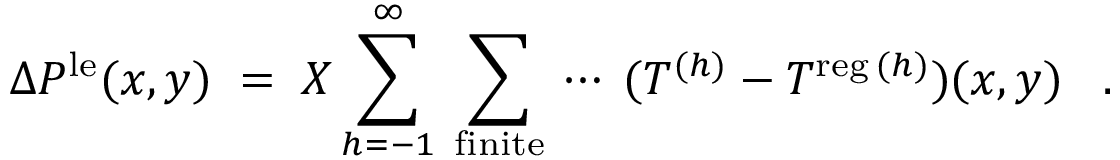Convert formula to latex. <formula><loc_0><loc_0><loc_500><loc_500>\Delta P ^ { l e } ( x , y ) \, = \, X \sum _ { h = - 1 } ^ { \infty } \, \sum _ { f i n i t e } \, \cdots \, ( T ^ { ( h ) } - T ^ { r e g \, ( h ) } ) ( x , y ) \, .</formula> 